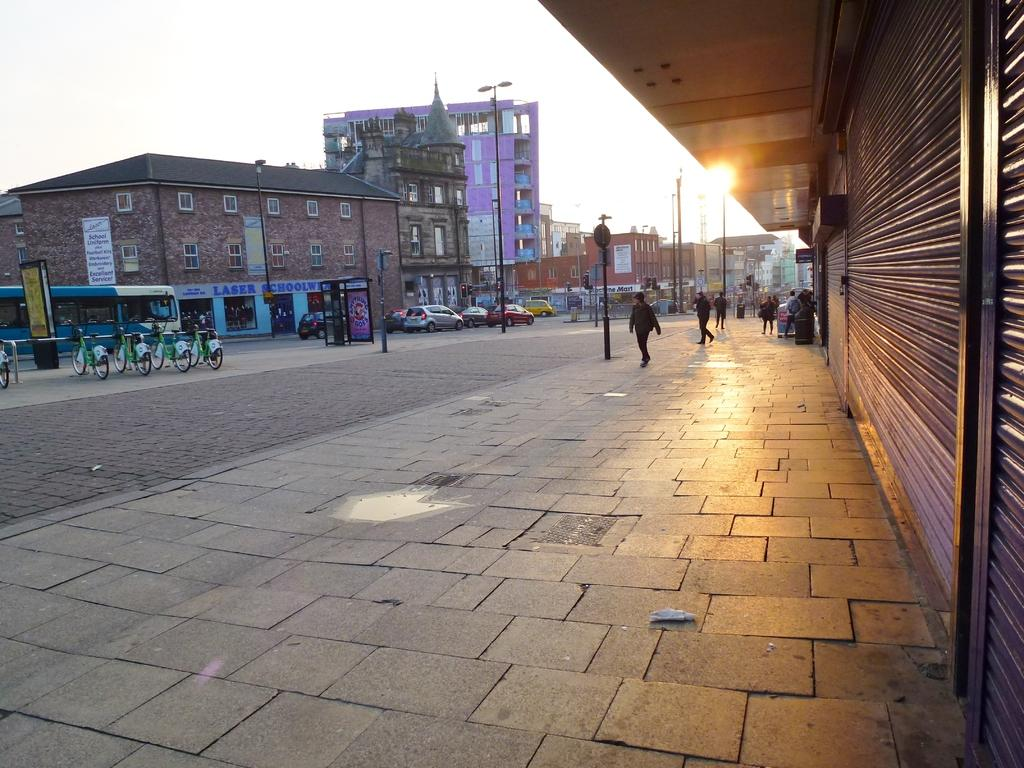What is the main subject of the image? The main subject of the image is a group of vehicles. Are there any people in the image? Yes, there are persons in the image. What can be seen behind the vehicles in the image? There is a group of buildings behind the vehicles. What type of structures are present in the image to provide illumination? Street poles with lights are present in the image. What is visible at the top of the image? The sky is visible at the top of the image. What type of plants can be seen growing near the seashore in the image? There is no seashore or plants present in the image; it features a group of vehicles, persons, buildings, street poles, and the sky. 